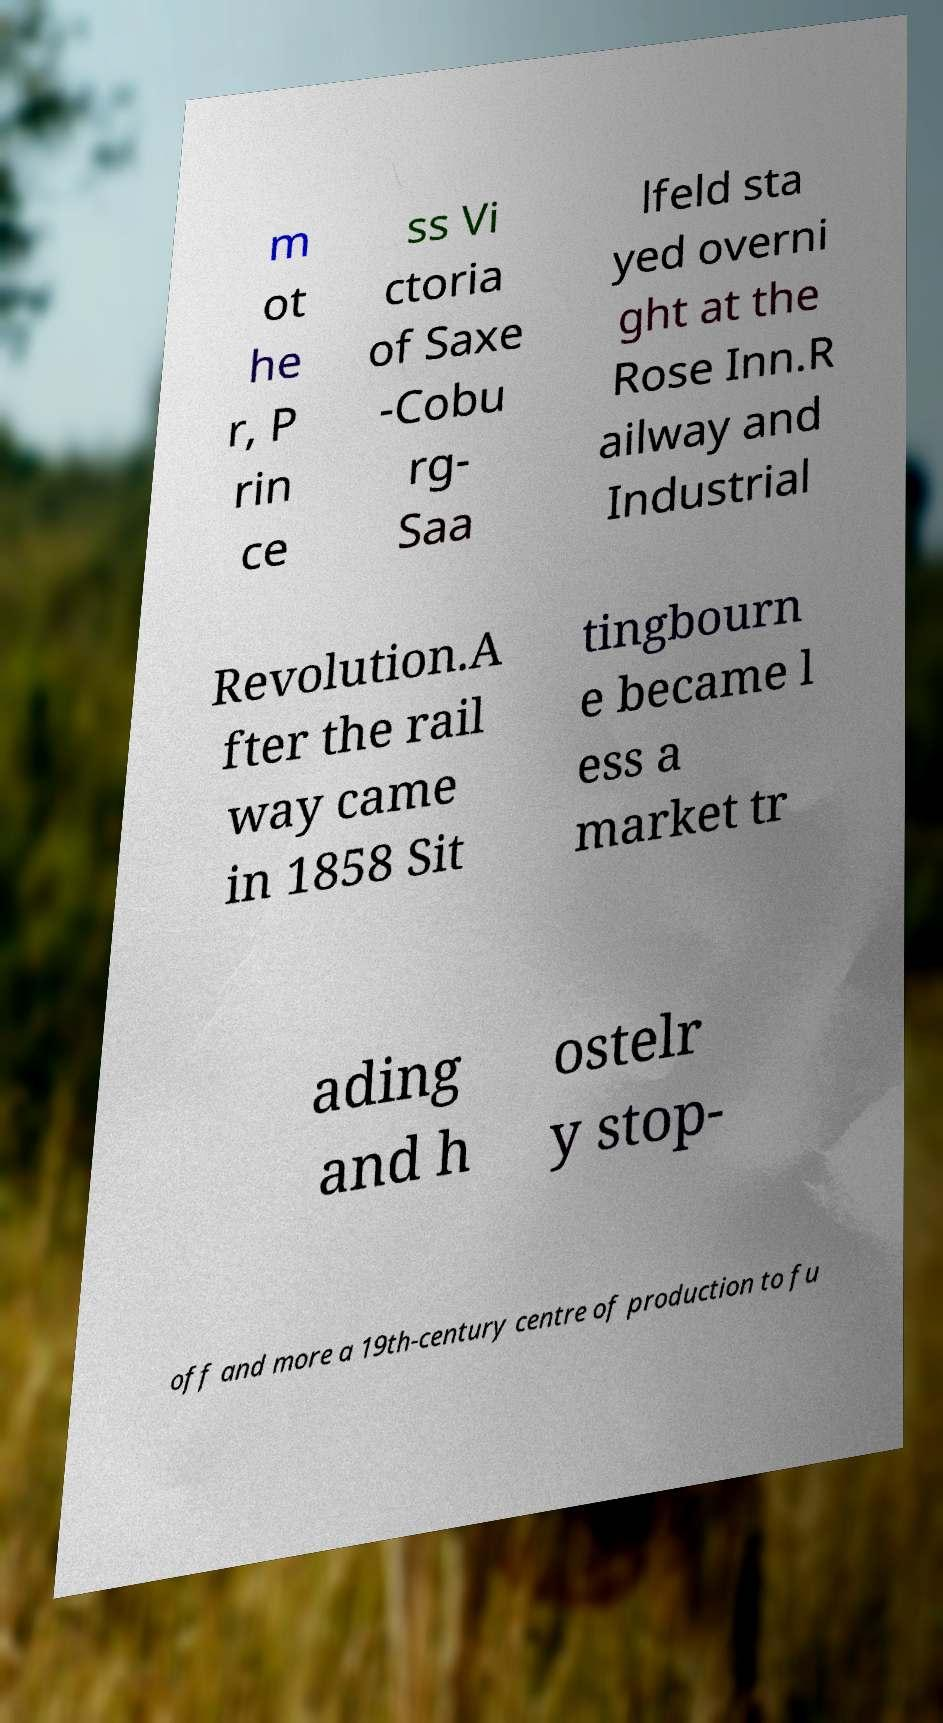Could you extract and type out the text from this image? m ot he r, P rin ce ss Vi ctoria of Saxe -Cobu rg- Saa lfeld sta yed overni ght at the Rose Inn.R ailway and Industrial Revolution.A fter the rail way came in 1858 Sit tingbourn e became l ess a market tr ading and h ostelr y stop- off and more a 19th-century centre of production to fu 